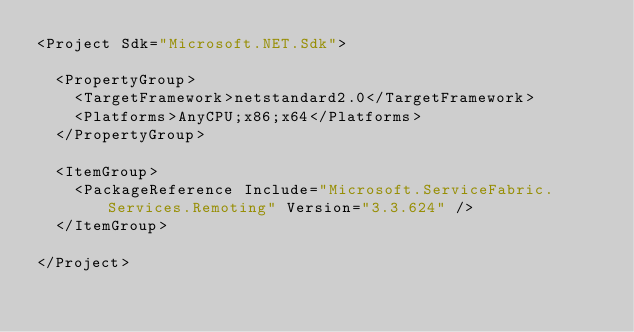<code> <loc_0><loc_0><loc_500><loc_500><_XML_><Project Sdk="Microsoft.NET.Sdk">

  <PropertyGroup>
    <TargetFramework>netstandard2.0</TargetFramework>
    <Platforms>AnyCPU;x86;x64</Platforms>
  </PropertyGroup>

  <ItemGroup>
    <PackageReference Include="Microsoft.ServiceFabric.Services.Remoting" Version="3.3.624" />
  </ItemGroup>

</Project>
</code> 